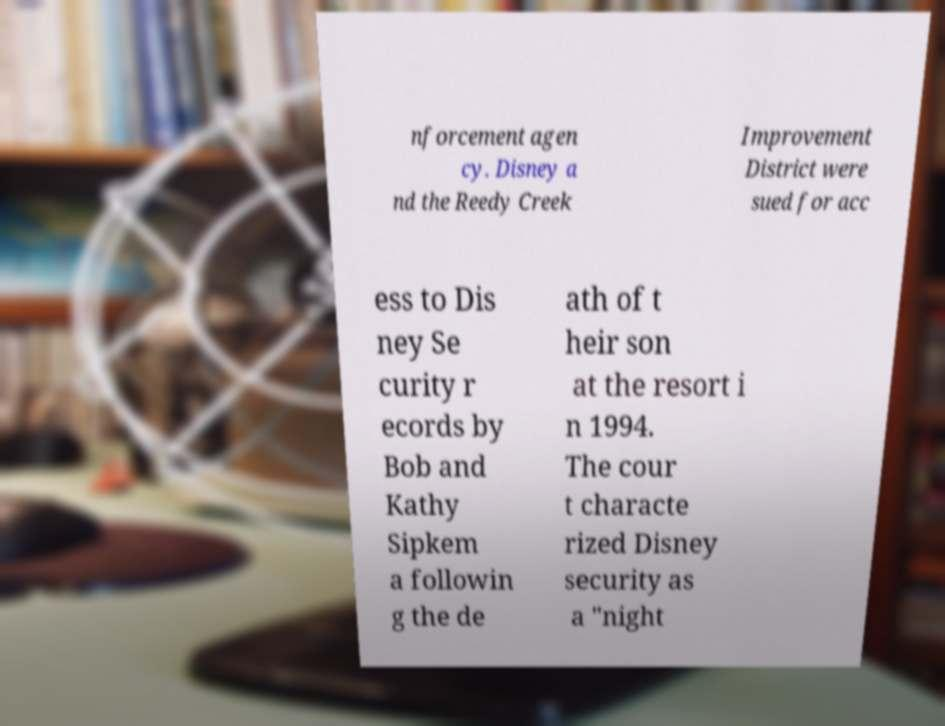Could you extract and type out the text from this image? nforcement agen cy. Disney a nd the Reedy Creek Improvement District were sued for acc ess to Dis ney Se curity r ecords by Bob and Kathy Sipkem a followin g the de ath of t heir son at the resort i n 1994. The cour t characte rized Disney security as a "night 